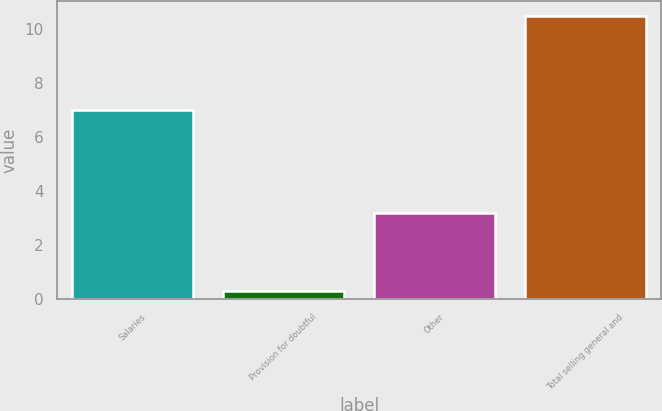Convert chart. <chart><loc_0><loc_0><loc_500><loc_500><bar_chart><fcel>Salaries<fcel>Provision for doubtful<fcel>Other<fcel>Total selling general and<nl><fcel>7<fcel>0.3<fcel>3.2<fcel>10.5<nl></chart> 